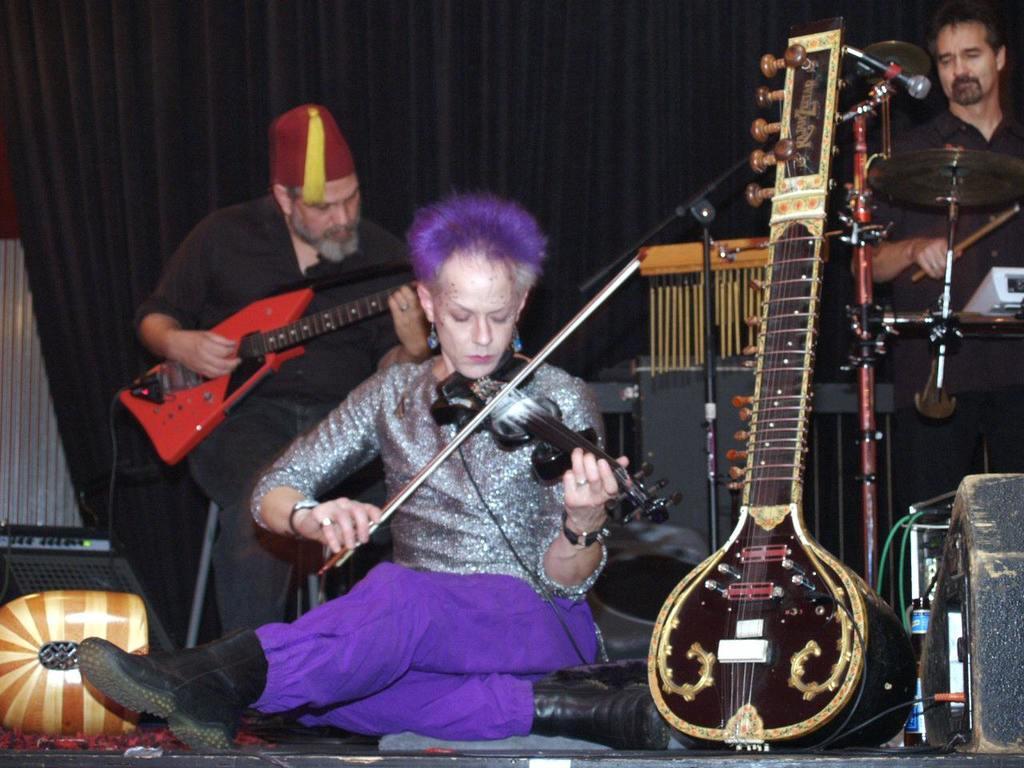How would you summarize this image in a sentence or two? In this image we can see a woman playing violin by sitting on the stage. There is veena in front of the image. In the background of the image we can see a man playing guitar and drums. 